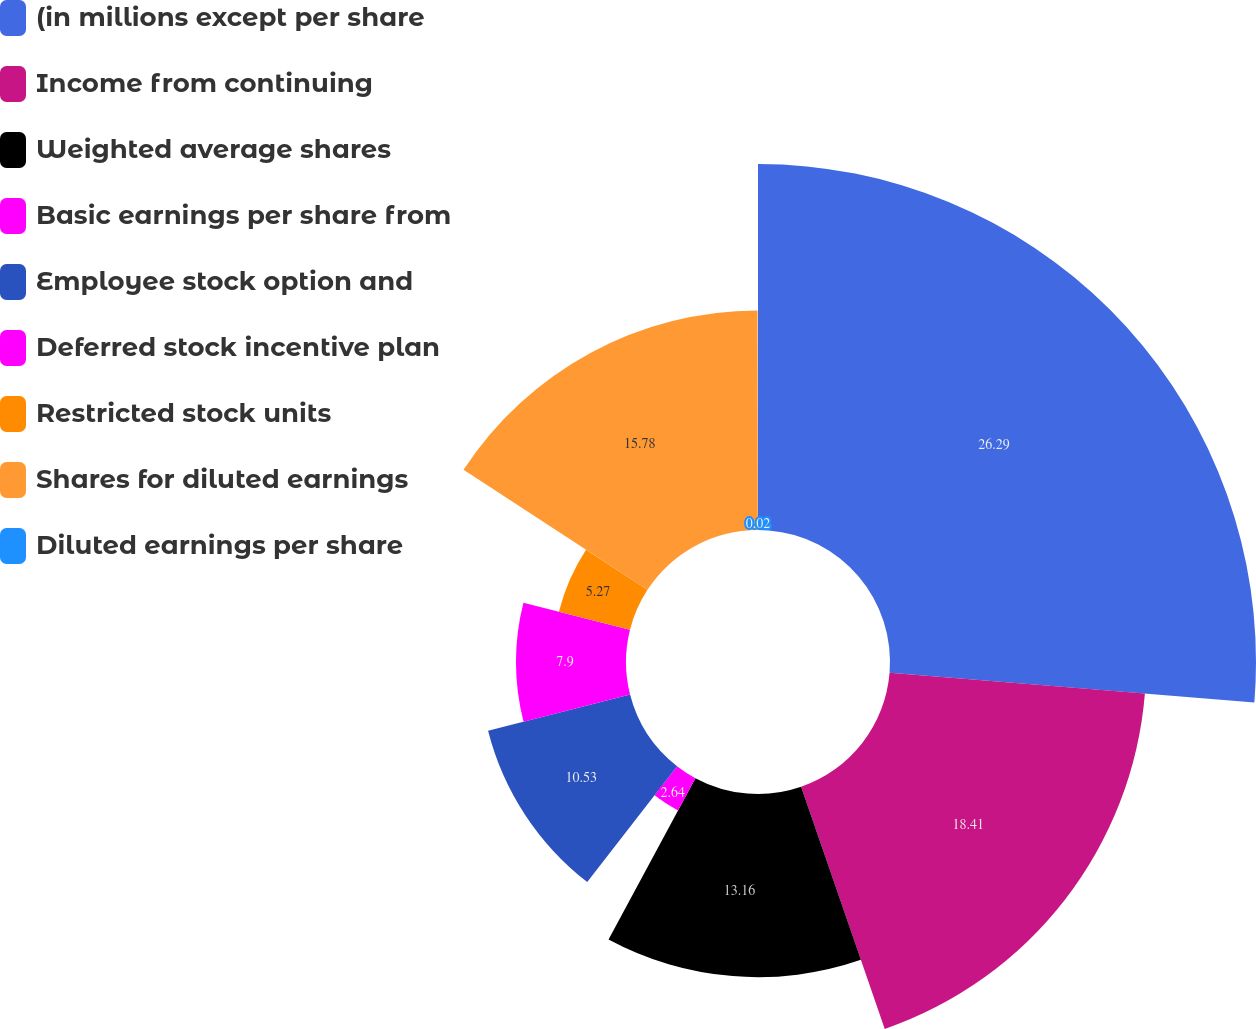<chart> <loc_0><loc_0><loc_500><loc_500><pie_chart><fcel>(in millions except per share<fcel>Income from continuing<fcel>Weighted average shares<fcel>Basic earnings per share from<fcel>Employee stock option and<fcel>Deferred stock incentive plan<fcel>Restricted stock units<fcel>Shares for diluted earnings<fcel>Diluted earnings per share<nl><fcel>26.3%<fcel>18.41%<fcel>13.16%<fcel>2.64%<fcel>10.53%<fcel>7.9%<fcel>5.27%<fcel>15.78%<fcel>0.02%<nl></chart> 